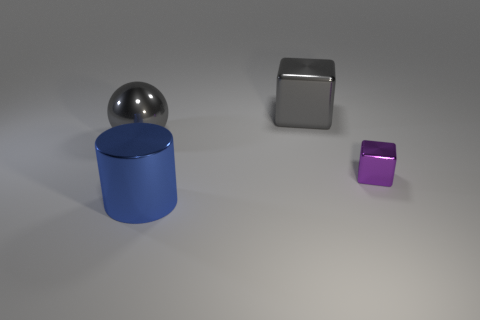Add 3 gray metallic blocks. How many objects exist? 7 Subtract 0 purple cylinders. How many objects are left? 4 Subtract all cylinders. How many objects are left? 3 Subtract 1 cylinders. How many cylinders are left? 0 Subtract all purple cylinders. Subtract all brown spheres. How many cylinders are left? 1 Subtract all purple cylinders. How many red cubes are left? 0 Subtract all small yellow metal cubes. Subtract all blue metallic cylinders. How many objects are left? 3 Add 3 metallic objects. How many metallic objects are left? 7 Add 2 balls. How many balls exist? 3 